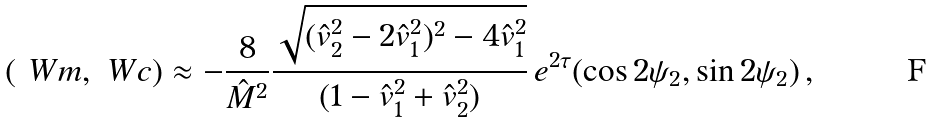Convert formula to latex. <formula><loc_0><loc_0><loc_500><loc_500>( \ W m , \ W c ) \approx - \frac { 8 } { \hat { M } ^ { 2 } } \frac { \sqrt { ( \hat { v } _ { 2 } ^ { 2 } - 2 \hat { v } _ { 1 } ^ { 2 } ) ^ { 2 } - 4 \hat { v } _ { 1 } ^ { 2 } } } { ( 1 - \hat { v } _ { 1 } ^ { 2 } + \hat { v } _ { 2 } ^ { 2 } ) } \, e ^ { 2 \tau } ( \cos 2 \psi _ { 2 } , \sin 2 \psi _ { 2 } ) \, ,</formula> 